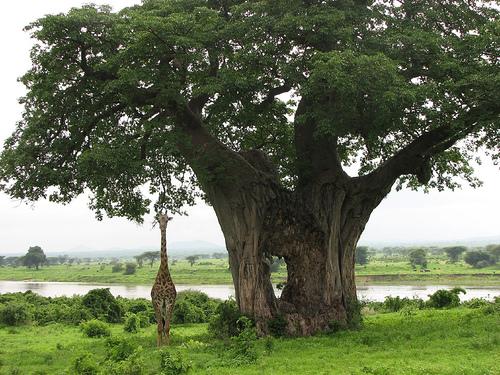Is the giraffe walking towards or away from you?
Answer briefly. Towards. Is there a body of water in this picture?
Answer briefly. Yes. How many animals?
Answer briefly. 1. 